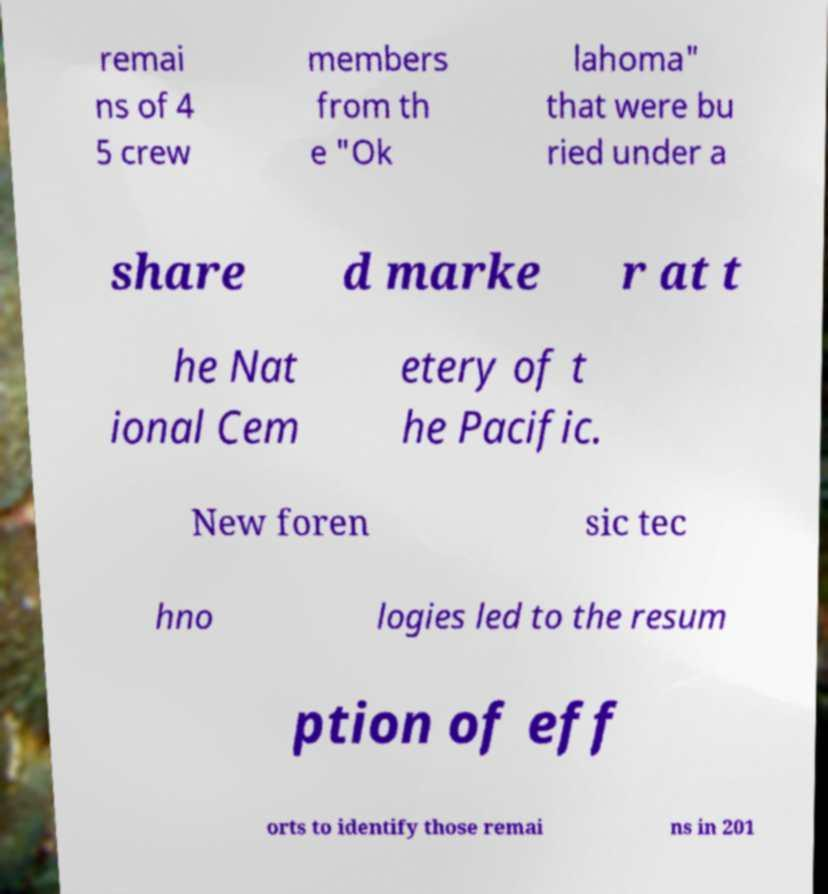There's text embedded in this image that I need extracted. Can you transcribe it verbatim? remai ns of 4 5 crew members from th e "Ok lahoma" that were bu ried under a share d marke r at t he Nat ional Cem etery of t he Pacific. New foren sic tec hno logies led to the resum ption of eff orts to identify those remai ns in 201 